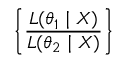Convert formula to latex. <formula><loc_0><loc_0><loc_500><loc_500>\left \{ { \frac { L ( \theta _ { 1 } | X ) } { L ( \theta _ { 2 } | X ) } } \right \}</formula> 